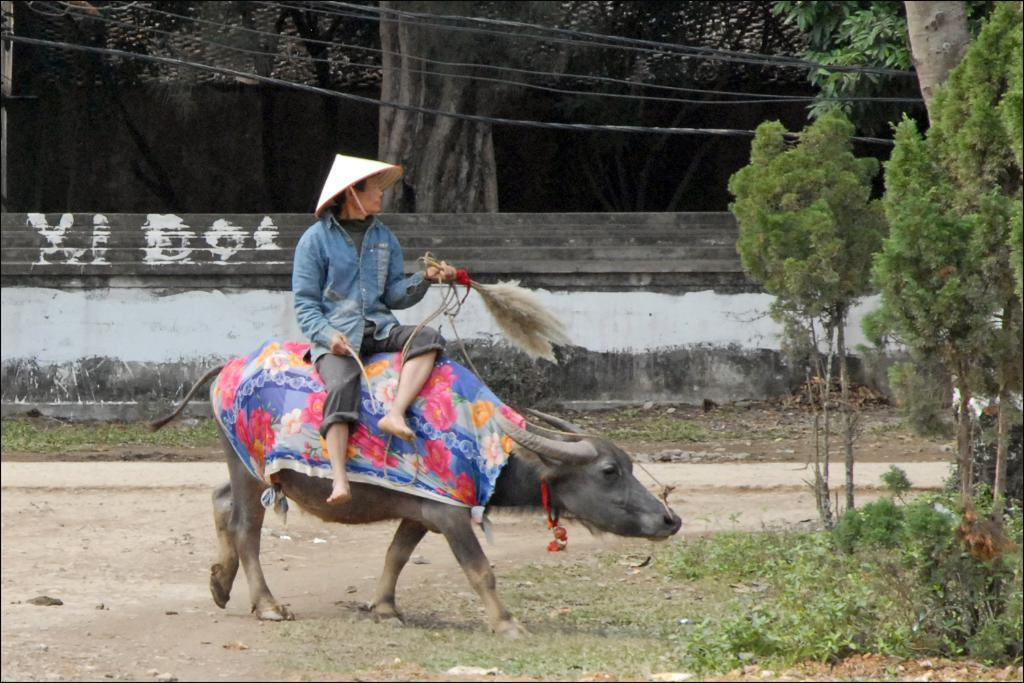What is the main subject of the image? There is a person sitting on a buffalo in the center of the image. What can be seen on the right side of the image? There are trees and plants on the right side of the image. What is visible in the background of the image? There is a wall, grass, and trees in the background of the image. What type of attraction can be seen in the image? There is no attraction present in the image; it features a person sitting on a buffalo with trees, plants, and a wall in the background. What is the taste of the silver in the image? There is no silver present in the image, so it is not possible to determine its taste. 